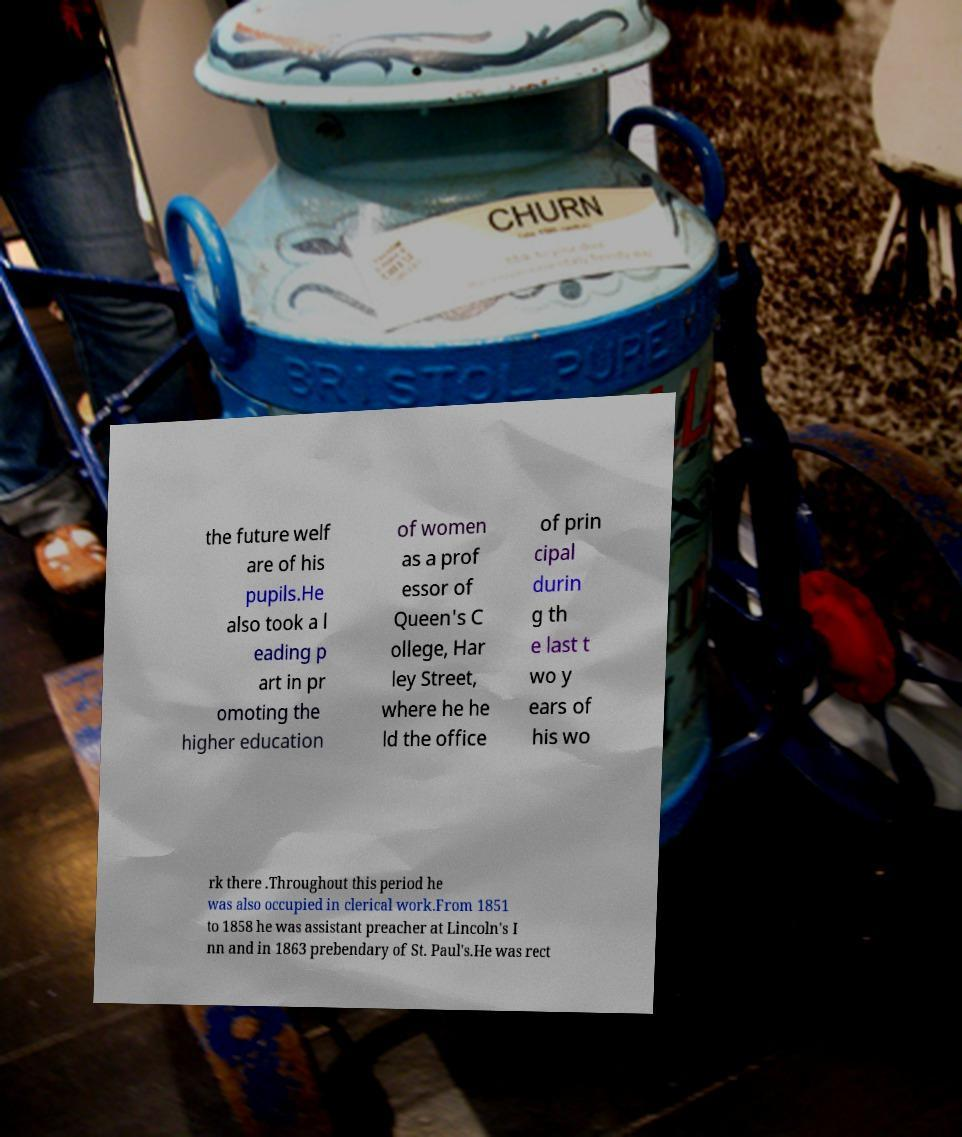Please identify and transcribe the text found in this image. the future welf are of his pupils.He also took a l eading p art in pr omoting the higher education of women as a prof essor of Queen's C ollege, Har ley Street, where he he ld the office of prin cipal durin g th e last t wo y ears of his wo rk there .Throughout this period he was also occupied in clerical work.From 1851 to 1858 he was assistant preacher at Lincoln's I nn and in 1863 prebendary of St. Paul's.He was rect 